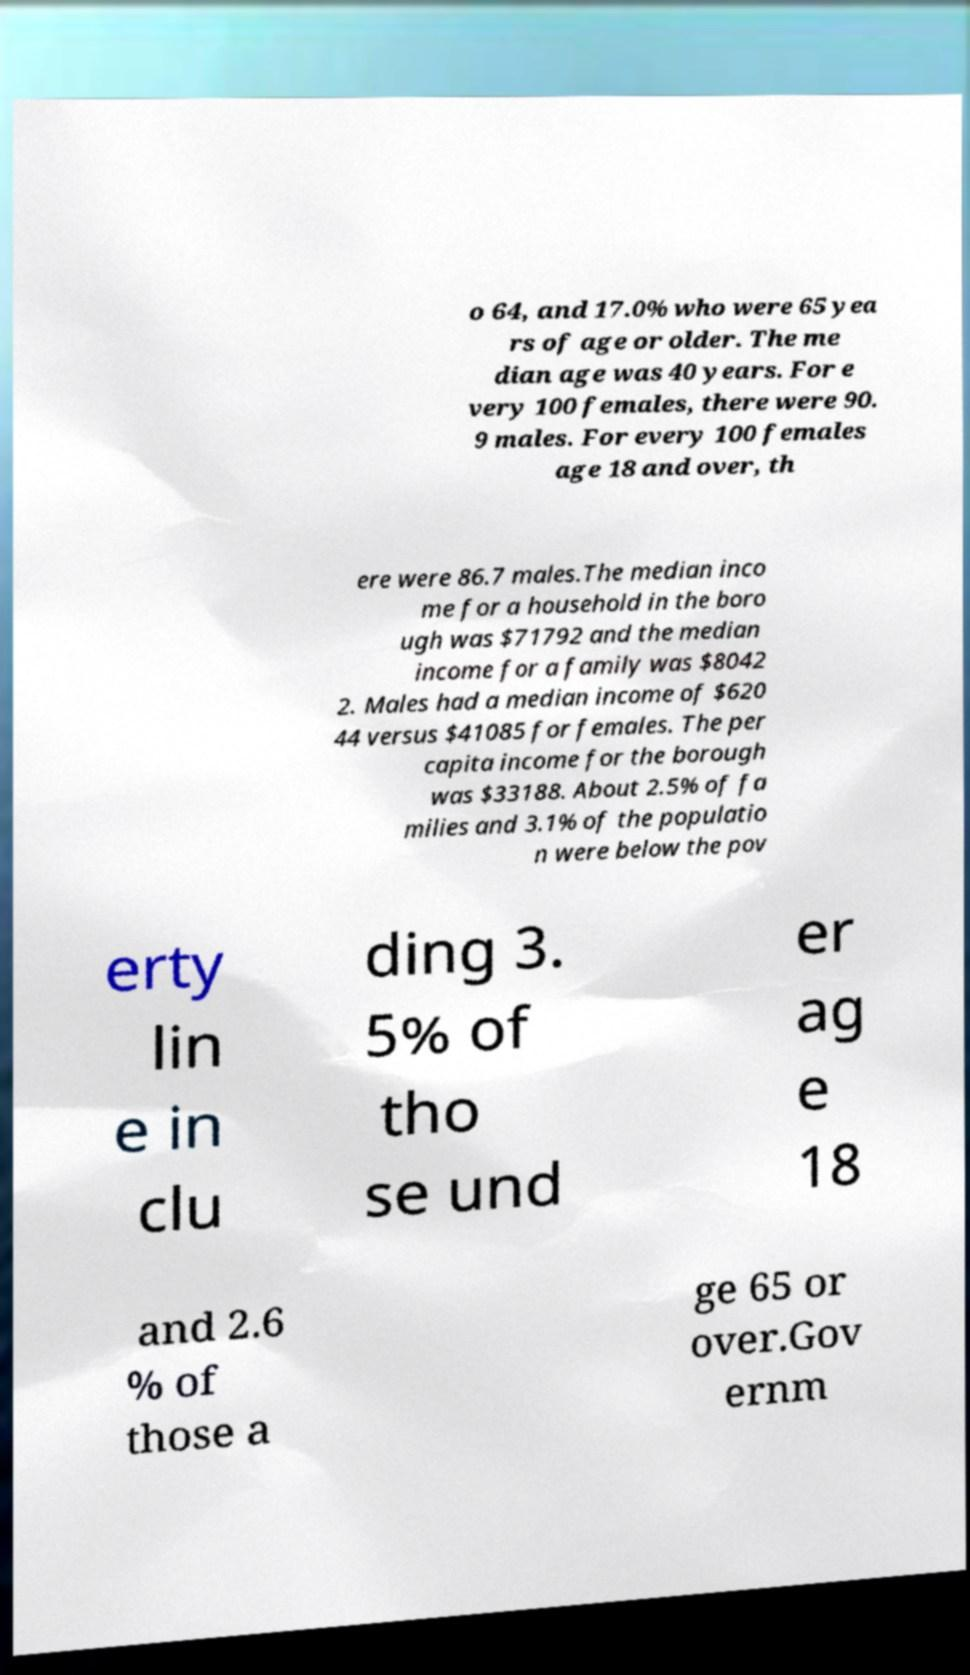Can you accurately transcribe the text from the provided image for me? o 64, and 17.0% who were 65 yea rs of age or older. The me dian age was 40 years. For e very 100 females, there were 90. 9 males. For every 100 females age 18 and over, th ere were 86.7 males.The median inco me for a household in the boro ugh was $71792 and the median income for a family was $8042 2. Males had a median income of $620 44 versus $41085 for females. The per capita income for the borough was $33188. About 2.5% of fa milies and 3.1% of the populatio n were below the pov erty lin e in clu ding 3. 5% of tho se und er ag e 18 and 2.6 % of those a ge 65 or over.Gov ernm 